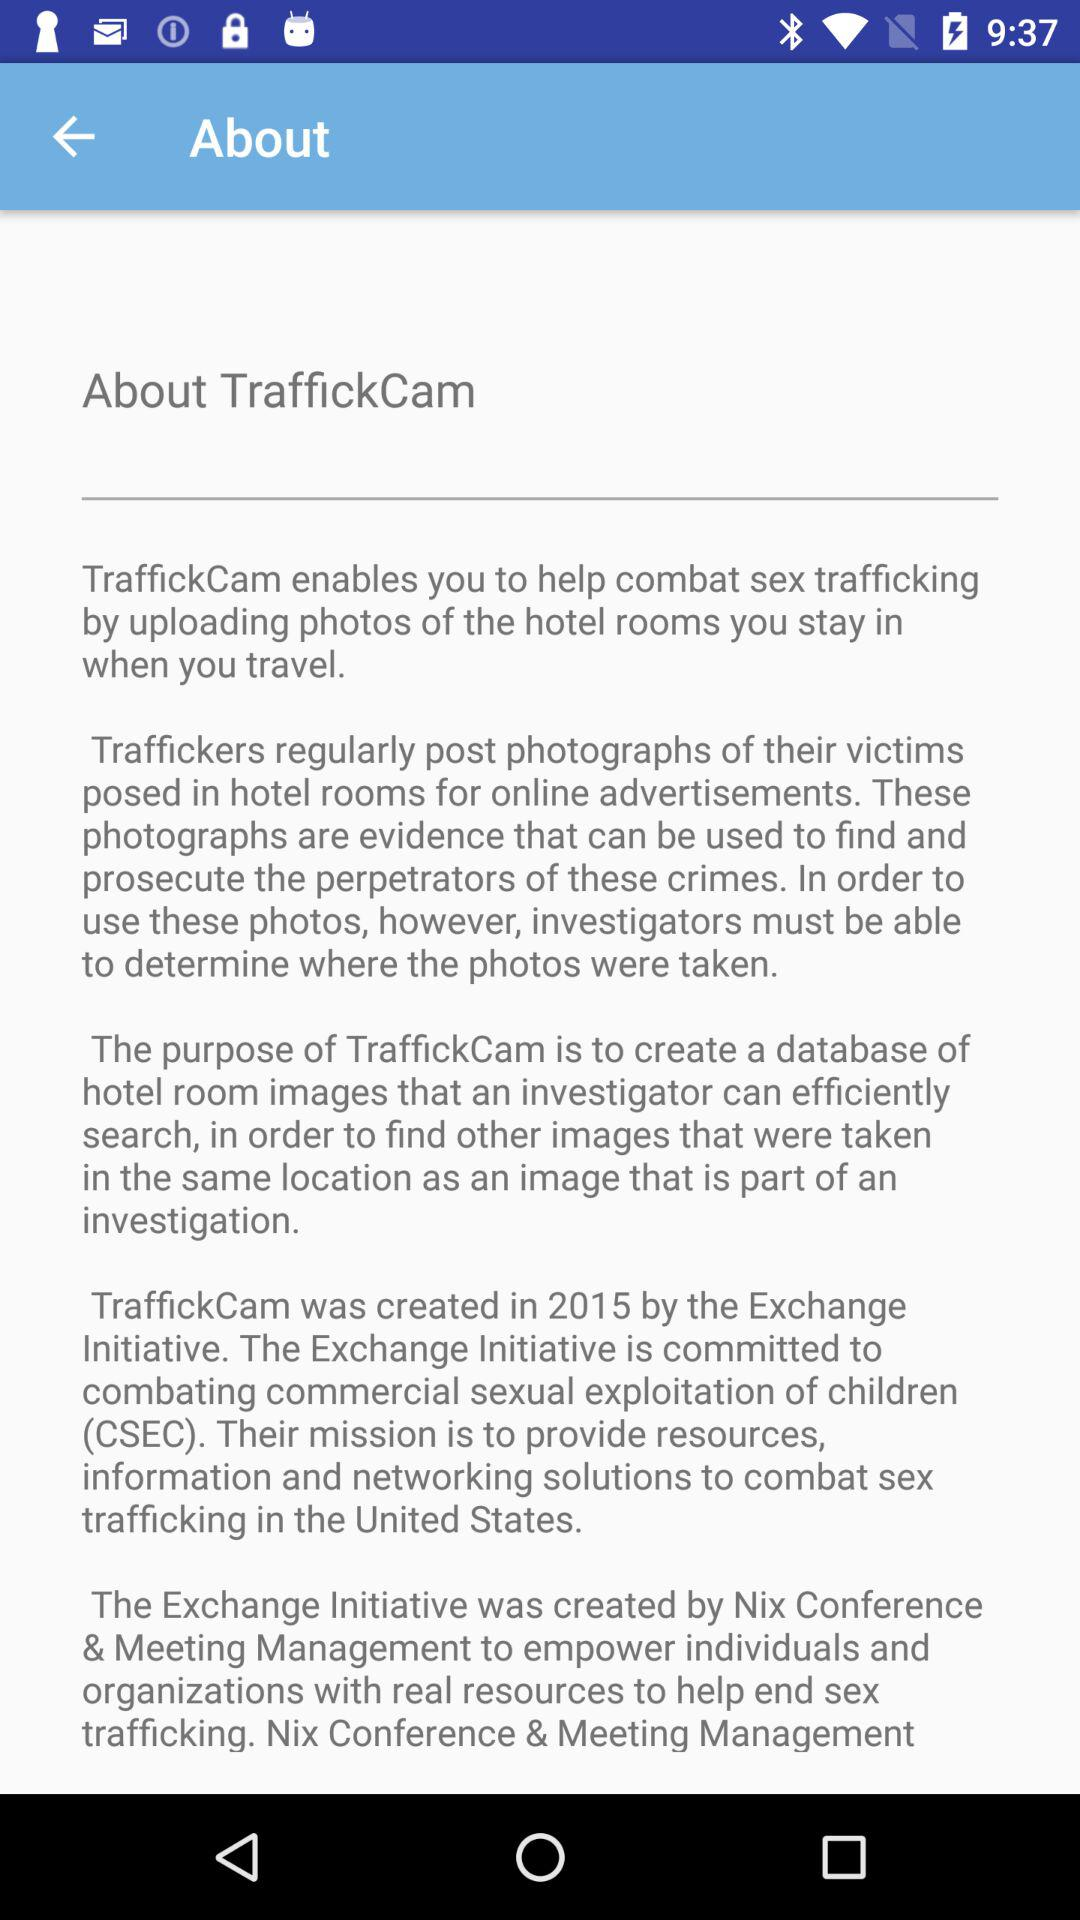Who created the application "TraffickCam"? The application "TraffickCam" was created by the "Exchange Initiative". 